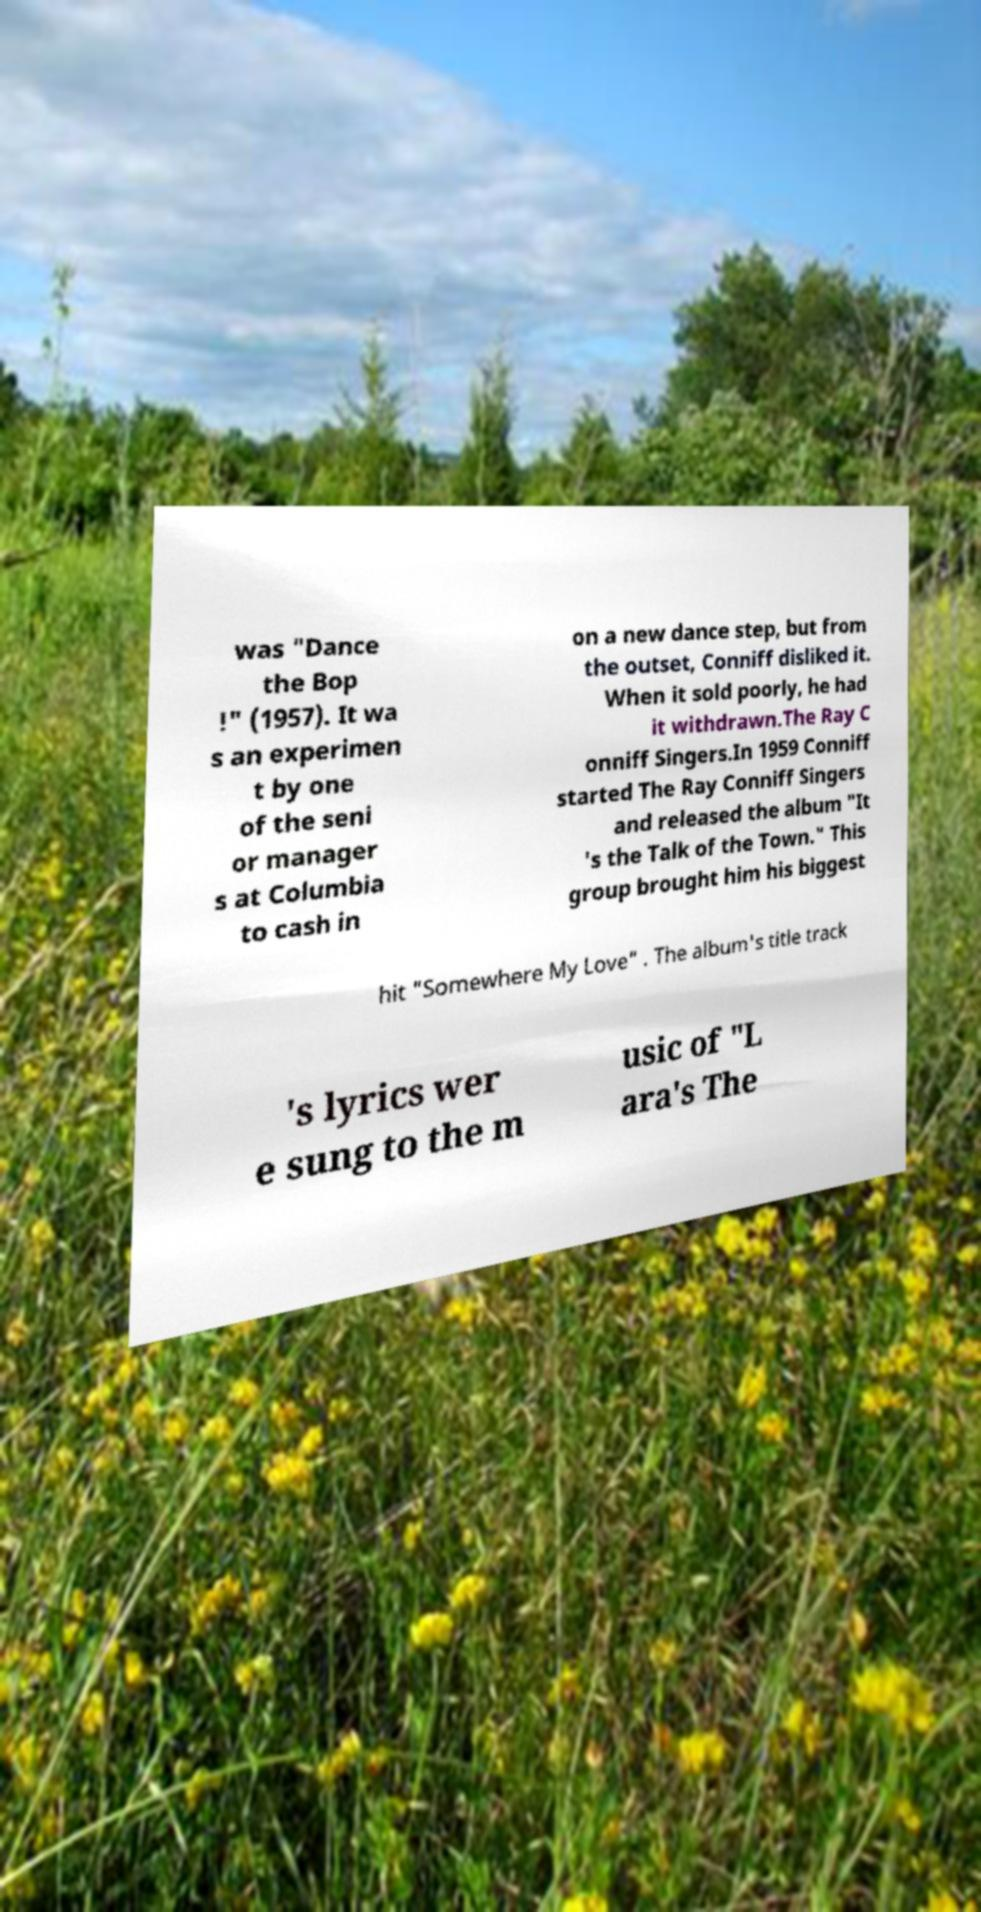Can you read and provide the text displayed in the image?This photo seems to have some interesting text. Can you extract and type it out for me? was "Dance the Bop !" (1957). It wa s an experimen t by one of the seni or manager s at Columbia to cash in on a new dance step, but from the outset, Conniff disliked it. When it sold poorly, he had it withdrawn.The Ray C onniff Singers.In 1959 Conniff started The Ray Conniff Singers and released the album "It 's the Talk of the Town." This group brought him his biggest hit "Somewhere My Love" . The album's title track 's lyrics wer e sung to the m usic of "L ara's The 